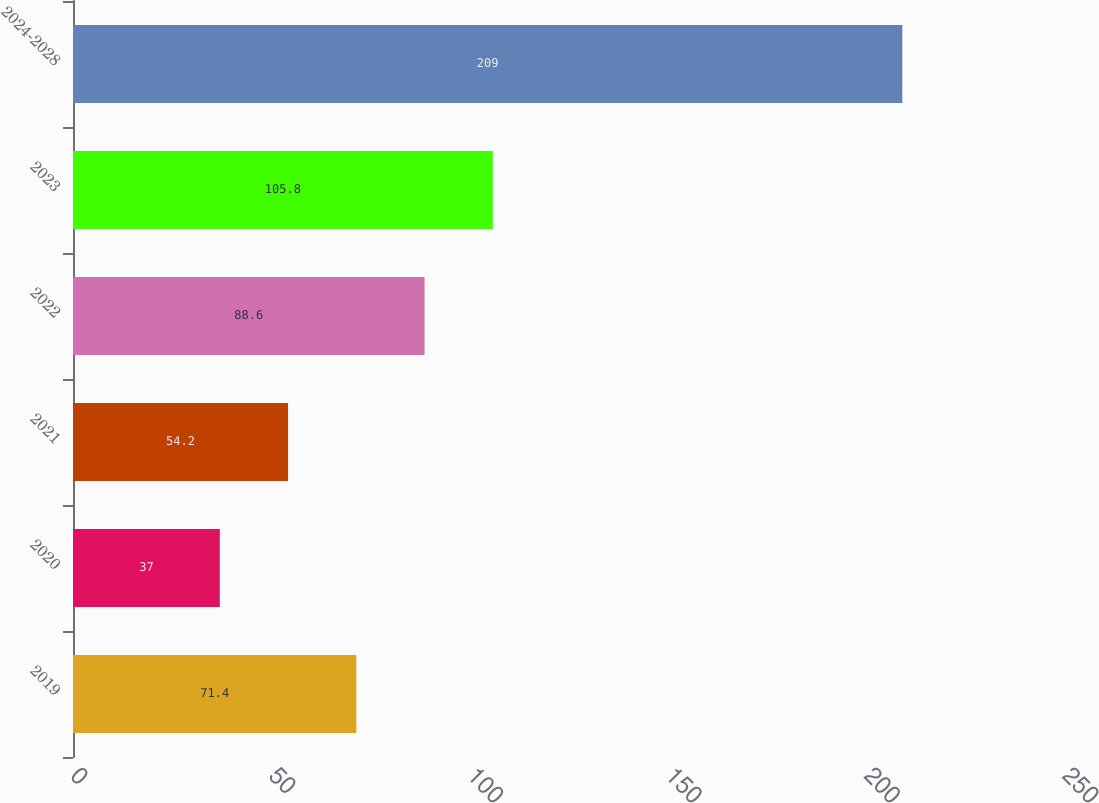Convert chart. <chart><loc_0><loc_0><loc_500><loc_500><bar_chart><fcel>2019<fcel>2020<fcel>2021<fcel>2022<fcel>2023<fcel>2024-2028<nl><fcel>71.4<fcel>37<fcel>54.2<fcel>88.6<fcel>105.8<fcel>209<nl></chart> 